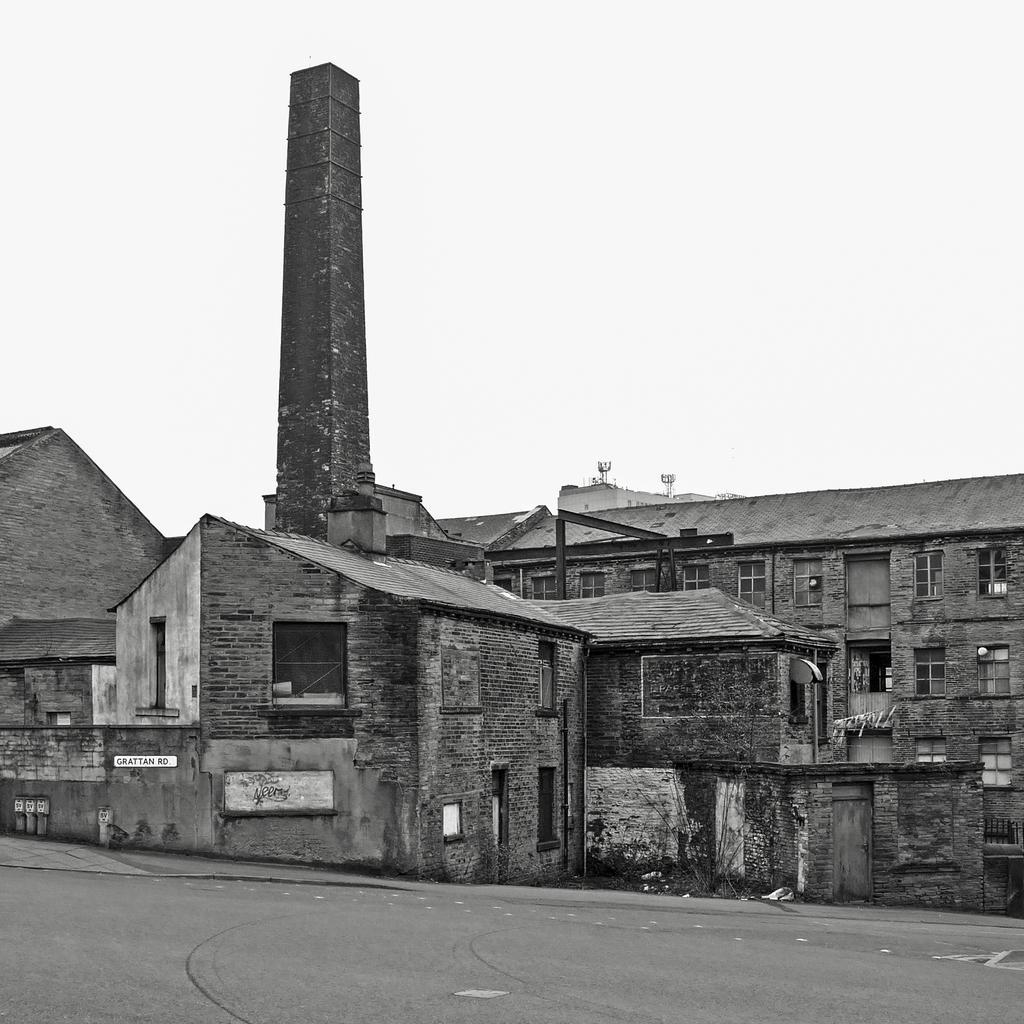In one or two sentences, can you explain what this image depicts? In this image we can see buildings, road and sky. 